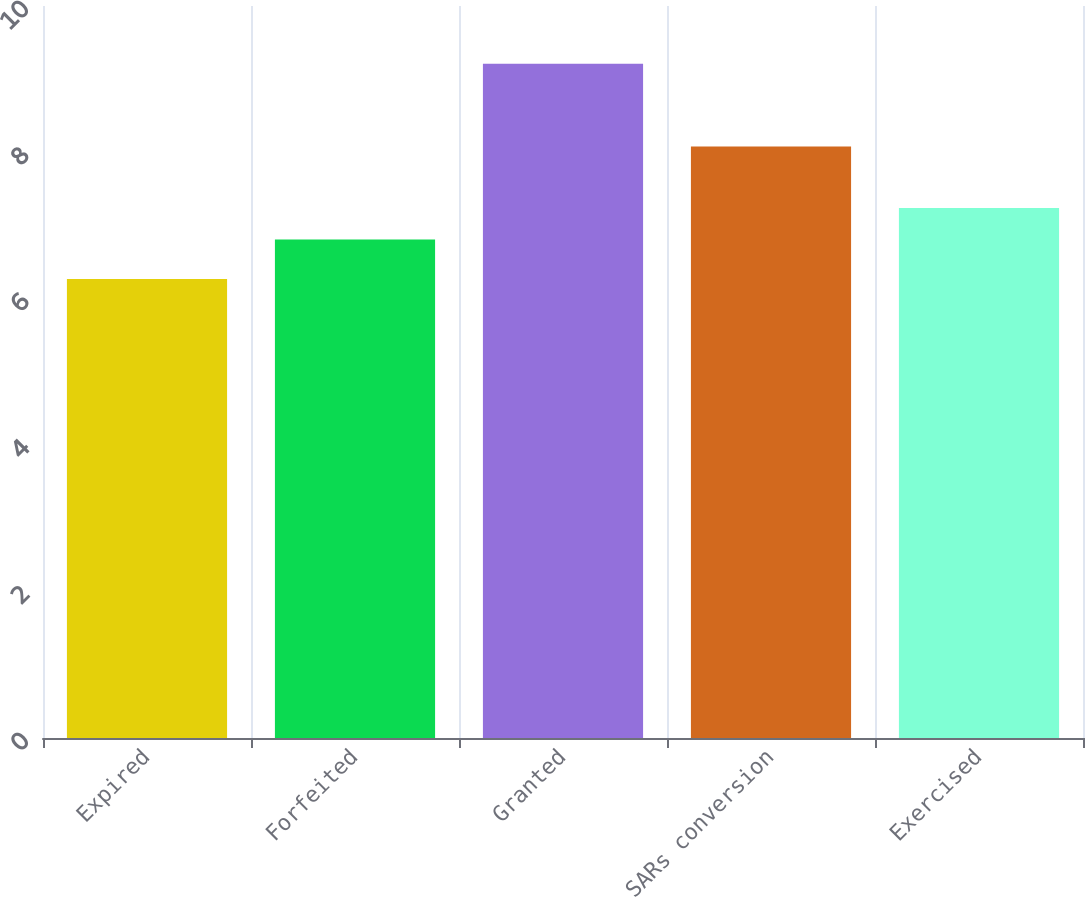Convert chart to OTSL. <chart><loc_0><loc_0><loc_500><loc_500><bar_chart><fcel>Expired<fcel>Forfeited<fcel>Granted<fcel>SARs conversion<fcel>Exercised<nl><fcel>6.27<fcel>6.81<fcel>9.21<fcel>8.08<fcel>7.24<nl></chart> 